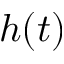Convert formula to latex. <formula><loc_0><loc_0><loc_500><loc_500>h ( t )</formula> 